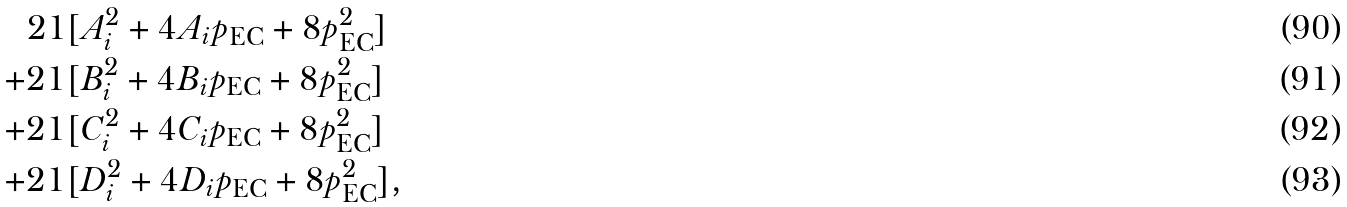Convert formula to latex. <formula><loc_0><loc_0><loc_500><loc_500>2 1 & [ A _ { i } ^ { 2 } + 4 A _ { i } p _ { \text {EC} } + 8 p _ { \text {EC} } ^ { 2 } ] \\ + 2 1 & [ B _ { i } ^ { 2 } + 4 B _ { i } p _ { \text {EC} } + 8 p _ { \text {EC} } ^ { 2 } ] \\ + 2 1 & [ C _ { i } ^ { 2 } + 4 C _ { i } p _ { \text {EC} } + 8 p _ { \text {EC} } ^ { 2 } ] \\ + 2 1 & [ D _ { i } ^ { 2 } + 4 D _ { i } p _ { \text {EC} } + 8 p _ { \text {EC} } ^ { 2 } ] ,</formula> 